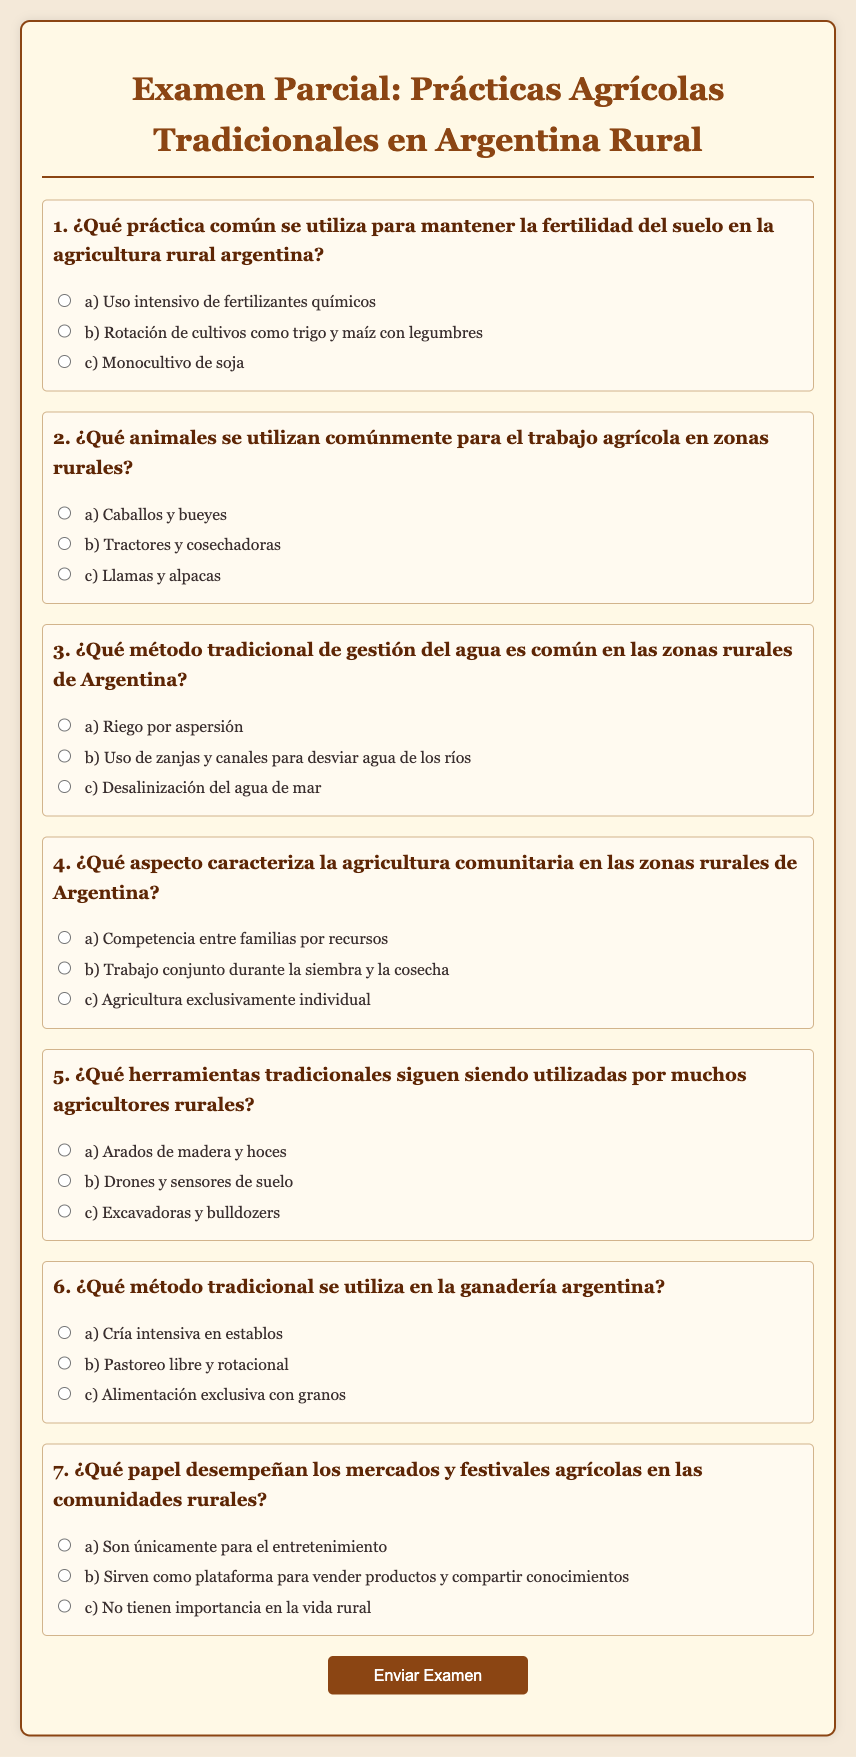¿Quién es el autor del examen? El documento no menciona un autor específico, ya que es un examen colectivo sobre prácticas agrícolas tradicionales.
Answer: Sin autor ¿Cuál es el propósito del examen? El propósito del examen es evaluar el conocimiento sobre prácticas agrícolas tradicionales en Argentina rural.
Answer: Evaluar conocimiento ¿Qué aspecto caracteriza la agricultura comunitaria según el documento? Según el documento, la agricultura comunitaria se caracteriza por el trabajo conjunto durante la siembra y la cosecha.
Answer: Trabajo conjunto ¿Cuáles son los animales mencionados para el trabajo agrícola? Se mencionan caballos y bueyes como animales comunes para el trabajo agrícola en zonas rurales.
Answer: Caballos y bueyes ¿Qué práctica se utiliza para mantener la fertilidad del suelo? La práctica utilizada para mantener la fertilidad del suelo es la rotación de cultivos como trigo y maíz con legumbres.
Answer: Rotación de cultivos ¿Qué herramienta tradicional aún se utiliza en el campo? Se utilizan arados de madera y hoces como herramientas tradicionales en la agricultura rural.
Answer: Arados de madera y hoces ¿Cuál es un método tradicional de gestión del agua? Un método tradicional de gestión del agua mencionado es el uso de zanjas y canales para desviar agua de los ríos.
Answer: Zanjas y canales ¿Qué papel juegan los mercados y festivales agrícolas? Los mercados y festivales agrícolas sirven como plataforma para vender productos y compartir conocimientos.
Answer: Plataforma para vender productos ¿Qué método tradicional se utiliza en la ganadería? El método tradicional utilizado en la ganadería argentina es el pastoreo libre y rotacional.
Answer: Pastoreo libre y rotacional 